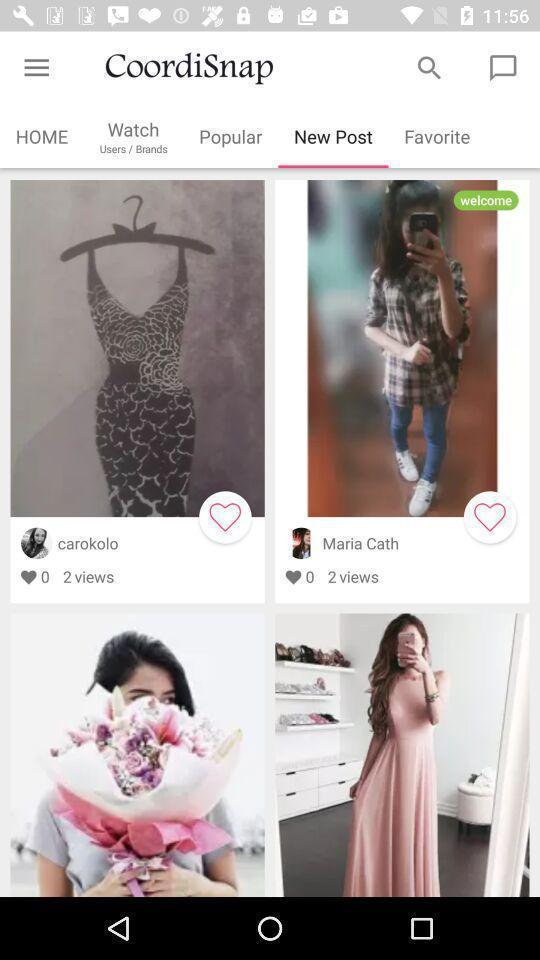Tell me about the visual elements in this screen capture. Screen displaying multiple users profile information. 